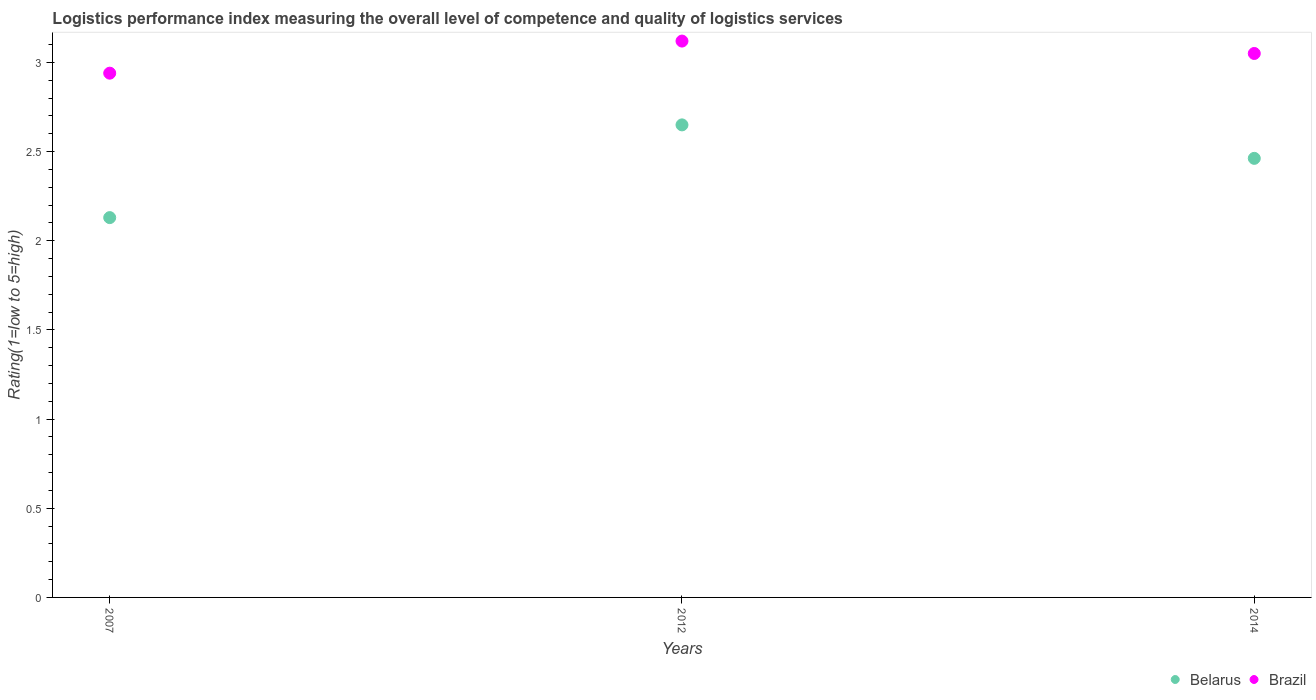Is the number of dotlines equal to the number of legend labels?
Provide a succinct answer. Yes. What is the Logistic performance index in Brazil in 2012?
Offer a terse response. 3.12. Across all years, what is the maximum Logistic performance index in Belarus?
Your answer should be compact. 2.65. Across all years, what is the minimum Logistic performance index in Brazil?
Your answer should be very brief. 2.94. In which year was the Logistic performance index in Brazil maximum?
Provide a short and direct response. 2012. In which year was the Logistic performance index in Brazil minimum?
Give a very brief answer. 2007. What is the total Logistic performance index in Belarus in the graph?
Provide a succinct answer. 7.24. What is the difference between the Logistic performance index in Brazil in 2007 and that in 2012?
Keep it short and to the point. -0.18. What is the difference between the Logistic performance index in Brazil in 2014 and the Logistic performance index in Belarus in 2007?
Provide a succinct answer. 0.92. What is the average Logistic performance index in Belarus per year?
Give a very brief answer. 2.41. In the year 2014, what is the difference between the Logistic performance index in Belarus and Logistic performance index in Brazil?
Your response must be concise. -0.59. In how many years, is the Logistic performance index in Brazil greater than 2.7?
Your answer should be very brief. 3. What is the ratio of the Logistic performance index in Belarus in 2007 to that in 2012?
Offer a terse response. 0.8. Is the difference between the Logistic performance index in Belarus in 2012 and 2014 greater than the difference between the Logistic performance index in Brazil in 2012 and 2014?
Offer a very short reply. Yes. What is the difference between the highest and the second highest Logistic performance index in Belarus?
Offer a very short reply. 0.19. What is the difference between the highest and the lowest Logistic performance index in Belarus?
Offer a terse response. 0.52. In how many years, is the Logistic performance index in Brazil greater than the average Logistic performance index in Brazil taken over all years?
Ensure brevity in your answer.  2. Is the Logistic performance index in Brazil strictly greater than the Logistic performance index in Belarus over the years?
Offer a terse response. Yes. Is the Logistic performance index in Brazil strictly less than the Logistic performance index in Belarus over the years?
Make the answer very short. No. How many dotlines are there?
Give a very brief answer. 2. How many years are there in the graph?
Offer a very short reply. 3. Are the values on the major ticks of Y-axis written in scientific E-notation?
Your answer should be very brief. No. Does the graph contain any zero values?
Offer a terse response. No. Where does the legend appear in the graph?
Your answer should be compact. Bottom right. How are the legend labels stacked?
Offer a terse response. Horizontal. What is the title of the graph?
Offer a terse response. Logistics performance index measuring the overall level of competence and quality of logistics services. Does "Bosnia and Herzegovina" appear as one of the legend labels in the graph?
Offer a terse response. No. What is the label or title of the Y-axis?
Your answer should be very brief. Rating(1=low to 5=high). What is the Rating(1=low to 5=high) of Belarus in 2007?
Provide a short and direct response. 2.13. What is the Rating(1=low to 5=high) of Brazil in 2007?
Your answer should be compact. 2.94. What is the Rating(1=low to 5=high) of Belarus in 2012?
Provide a short and direct response. 2.65. What is the Rating(1=low to 5=high) in Brazil in 2012?
Offer a very short reply. 3.12. What is the Rating(1=low to 5=high) in Belarus in 2014?
Your answer should be very brief. 2.46. What is the Rating(1=low to 5=high) of Brazil in 2014?
Ensure brevity in your answer.  3.05. Across all years, what is the maximum Rating(1=low to 5=high) in Belarus?
Ensure brevity in your answer.  2.65. Across all years, what is the maximum Rating(1=low to 5=high) in Brazil?
Offer a very short reply. 3.12. Across all years, what is the minimum Rating(1=low to 5=high) of Belarus?
Offer a very short reply. 2.13. Across all years, what is the minimum Rating(1=low to 5=high) in Brazil?
Keep it short and to the point. 2.94. What is the total Rating(1=low to 5=high) of Belarus in the graph?
Provide a short and direct response. 7.24. What is the total Rating(1=low to 5=high) in Brazil in the graph?
Provide a succinct answer. 9.11. What is the difference between the Rating(1=low to 5=high) in Belarus in 2007 and that in 2012?
Your answer should be very brief. -0.52. What is the difference between the Rating(1=low to 5=high) in Brazil in 2007 and that in 2012?
Offer a very short reply. -0.18. What is the difference between the Rating(1=low to 5=high) in Belarus in 2007 and that in 2014?
Ensure brevity in your answer.  -0.33. What is the difference between the Rating(1=low to 5=high) in Brazil in 2007 and that in 2014?
Your response must be concise. -0.11. What is the difference between the Rating(1=low to 5=high) of Belarus in 2012 and that in 2014?
Make the answer very short. 0.19. What is the difference between the Rating(1=low to 5=high) in Brazil in 2012 and that in 2014?
Your answer should be very brief. 0.07. What is the difference between the Rating(1=low to 5=high) in Belarus in 2007 and the Rating(1=low to 5=high) in Brazil in 2012?
Provide a short and direct response. -0.99. What is the difference between the Rating(1=low to 5=high) of Belarus in 2007 and the Rating(1=low to 5=high) of Brazil in 2014?
Your answer should be very brief. -0.92. What is the difference between the Rating(1=low to 5=high) of Belarus in 2012 and the Rating(1=low to 5=high) of Brazil in 2014?
Your answer should be compact. -0.4. What is the average Rating(1=low to 5=high) in Belarus per year?
Ensure brevity in your answer.  2.41. What is the average Rating(1=low to 5=high) of Brazil per year?
Give a very brief answer. 3.04. In the year 2007, what is the difference between the Rating(1=low to 5=high) of Belarus and Rating(1=low to 5=high) of Brazil?
Your response must be concise. -0.81. In the year 2012, what is the difference between the Rating(1=low to 5=high) of Belarus and Rating(1=low to 5=high) of Brazil?
Ensure brevity in your answer.  -0.47. In the year 2014, what is the difference between the Rating(1=low to 5=high) in Belarus and Rating(1=low to 5=high) in Brazil?
Ensure brevity in your answer.  -0.59. What is the ratio of the Rating(1=low to 5=high) in Belarus in 2007 to that in 2012?
Ensure brevity in your answer.  0.8. What is the ratio of the Rating(1=low to 5=high) of Brazil in 2007 to that in 2012?
Offer a terse response. 0.94. What is the ratio of the Rating(1=low to 5=high) in Belarus in 2007 to that in 2014?
Offer a very short reply. 0.86. What is the ratio of the Rating(1=low to 5=high) in Brazil in 2007 to that in 2014?
Offer a very short reply. 0.96. What is the ratio of the Rating(1=low to 5=high) in Belarus in 2012 to that in 2014?
Provide a succinct answer. 1.08. What is the ratio of the Rating(1=low to 5=high) in Brazil in 2012 to that in 2014?
Your answer should be compact. 1.02. What is the difference between the highest and the second highest Rating(1=low to 5=high) of Belarus?
Give a very brief answer. 0.19. What is the difference between the highest and the second highest Rating(1=low to 5=high) of Brazil?
Offer a very short reply. 0.07. What is the difference between the highest and the lowest Rating(1=low to 5=high) in Belarus?
Your answer should be compact. 0.52. What is the difference between the highest and the lowest Rating(1=low to 5=high) of Brazil?
Make the answer very short. 0.18. 